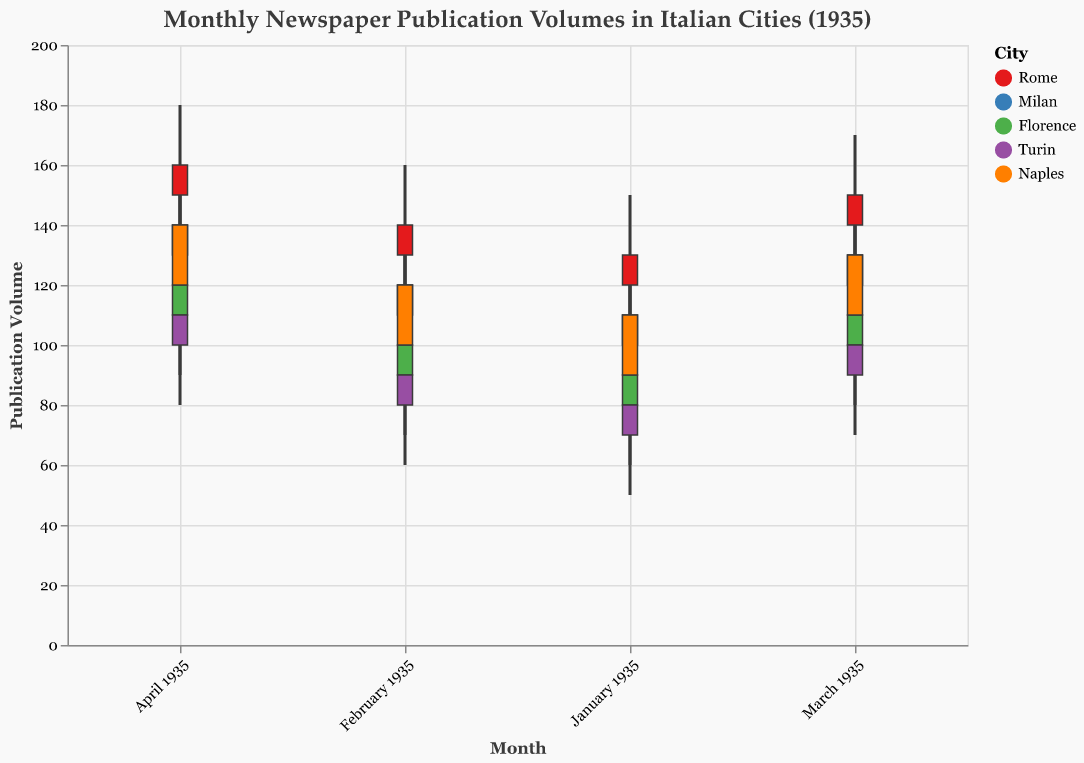what is the lowest publication volume in Florence for January 1935? The lows for each candlestick represent the lowest publication volume for that month. For Florence in January, the low is at 60.
Answer: 60 In which month did Milan see the highest publication volume, and what was it? The vertical ends above each candlestick represent the highest publication volume in that month. In Milan, the highest publication volume occurred in April with 160.
Answer: April, 160 Which city has the most consistent newspaper publication volumes over the months? To determine consistency, we look at the range between the high and low values for each month and compare their variation. Rome shows a steady increase in volumes without erratic changes, indicating consistent growth.
Answer: Rome Calculate the average closing volume in Naples from January to April 1935. Sum up all the closing volumes for Naples from January (110), February (120), March (130), and April (140). Then, divide by 4. The calculation is (110 + 120 + 130 + 140) / 4 = 500 / 4 = 125.
Answer: 125 Which city saw the largest increase in closing publication volumes from January to February 1935? Compare the closing publication volumes for January and February for each city. Rome: 10 increase (130 to 140), Milan: 10 (110 to 120), Florence: 10 (90 to 100), Turin: 10 (80 to 90), Naples: 10 (110 to 120). All cities saw an equal increase.
Answer: All cities Which city had the highest opening publication volume in March 1935, and what was it? Look at the opening values for each city in March 1935. Rome's opening volume is 140, Milan's is 120, Florence's is 100, Turin's is 90, and Naples's is 110. Rome had the highest opening volume at 140.
Answer: Rome, 140 Compare the range of publication volumes in Rome and Milan for April 1935. Which city had a larger range? For each city in April, subtract the low value from the high value. Rome: 180 - 130 = 50. Milan: 160 - 110 = 50. Both cities had an equal range.
Answer: Equal What pattern can you observe in the monthly newspaper publication volumes for Turin? The opening and close volumes in Turin show a steady increase month by month from January (open 70, close 80) to April (open 100, close 110).
Answer: Steady increase What was the difference between the highest publication volume of Rome and the lowest publication volume of Turin in April 1935? In April 1935, the highest publication volume in Rome was 180, and the lowest in Turin was 80. The difference is 180 - 80 = 100.
Answer: 100 